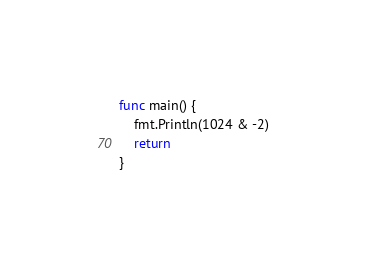Convert code to text. <code><loc_0><loc_0><loc_500><loc_500><_Go_>
func main() {
	fmt.Println(1024 & -2)
	return
}
</code> 